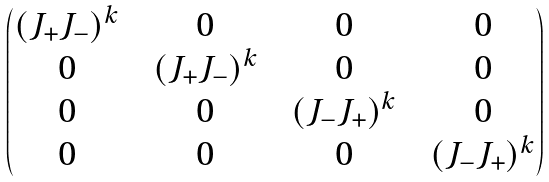<formula> <loc_0><loc_0><loc_500><loc_500>\begin{pmatrix} ( J _ { + } J _ { - } ) ^ { k } & & 0 & & 0 & & 0 \\ 0 & & ( J _ { + } J _ { - } ) ^ { k } & & 0 & & 0 \\ 0 & & 0 & & ( J _ { - } J _ { + } ) ^ { k } & & 0 \\ 0 & & 0 & & 0 & & ( J _ { - } J _ { + } ) ^ { k } \end{pmatrix}</formula> 